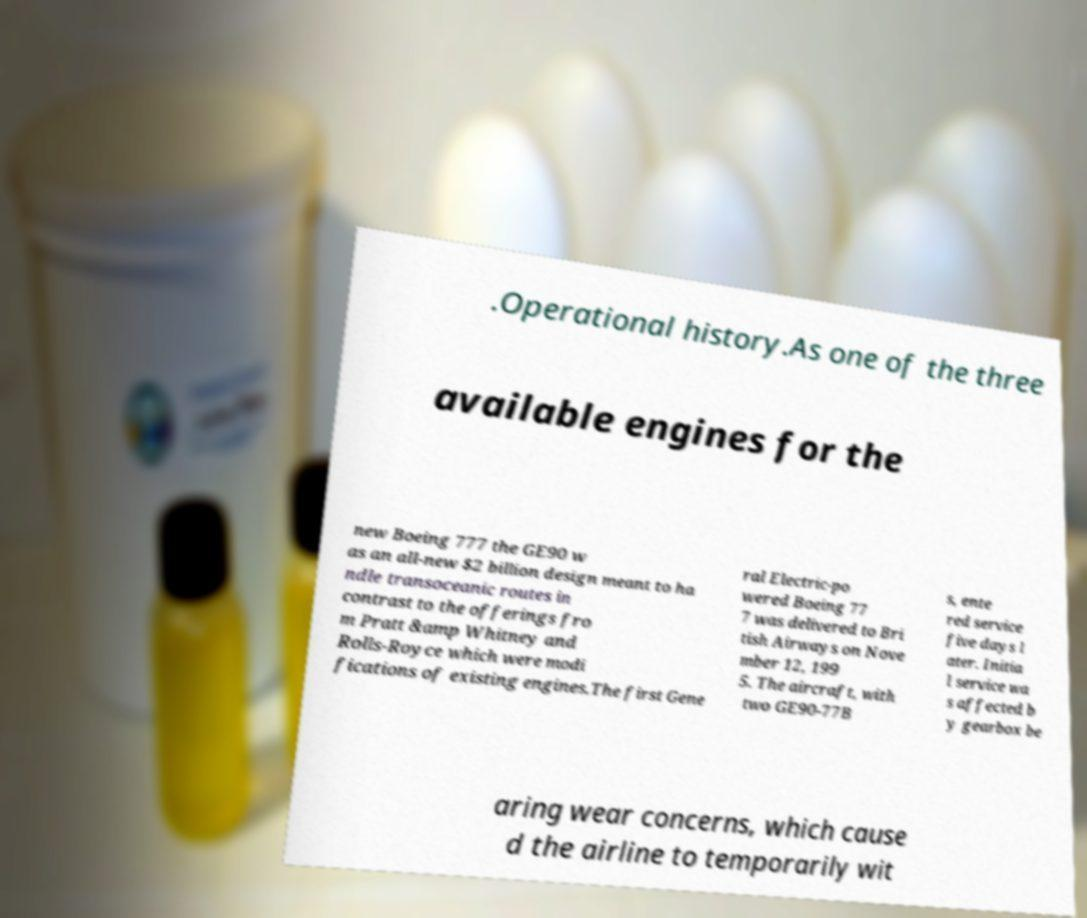Please identify and transcribe the text found in this image. .Operational history.As one of the three available engines for the new Boeing 777 the GE90 w as an all-new $2 billion design meant to ha ndle transoceanic routes in contrast to the offerings fro m Pratt &amp Whitney and Rolls-Royce which were modi fications of existing engines.The first Gene ral Electric-po wered Boeing 77 7 was delivered to Bri tish Airways on Nove mber 12, 199 5. The aircraft, with two GE90-77B s, ente red service five days l ater. Initia l service wa s affected b y gearbox be aring wear concerns, which cause d the airline to temporarily wit 